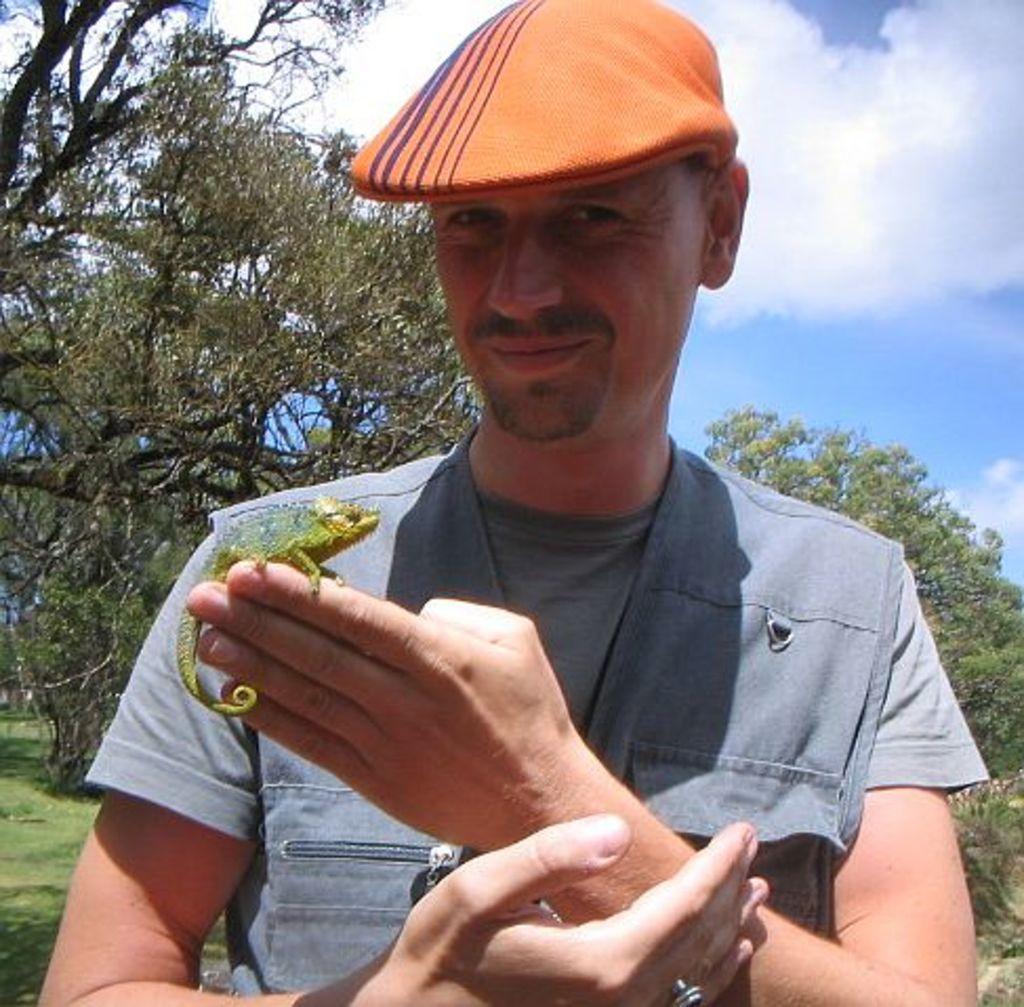Could you give a brief overview of what you see in this image? In this image we can see an animal on the hand of a person. In the background we can see group of trees and cloudy sky. 